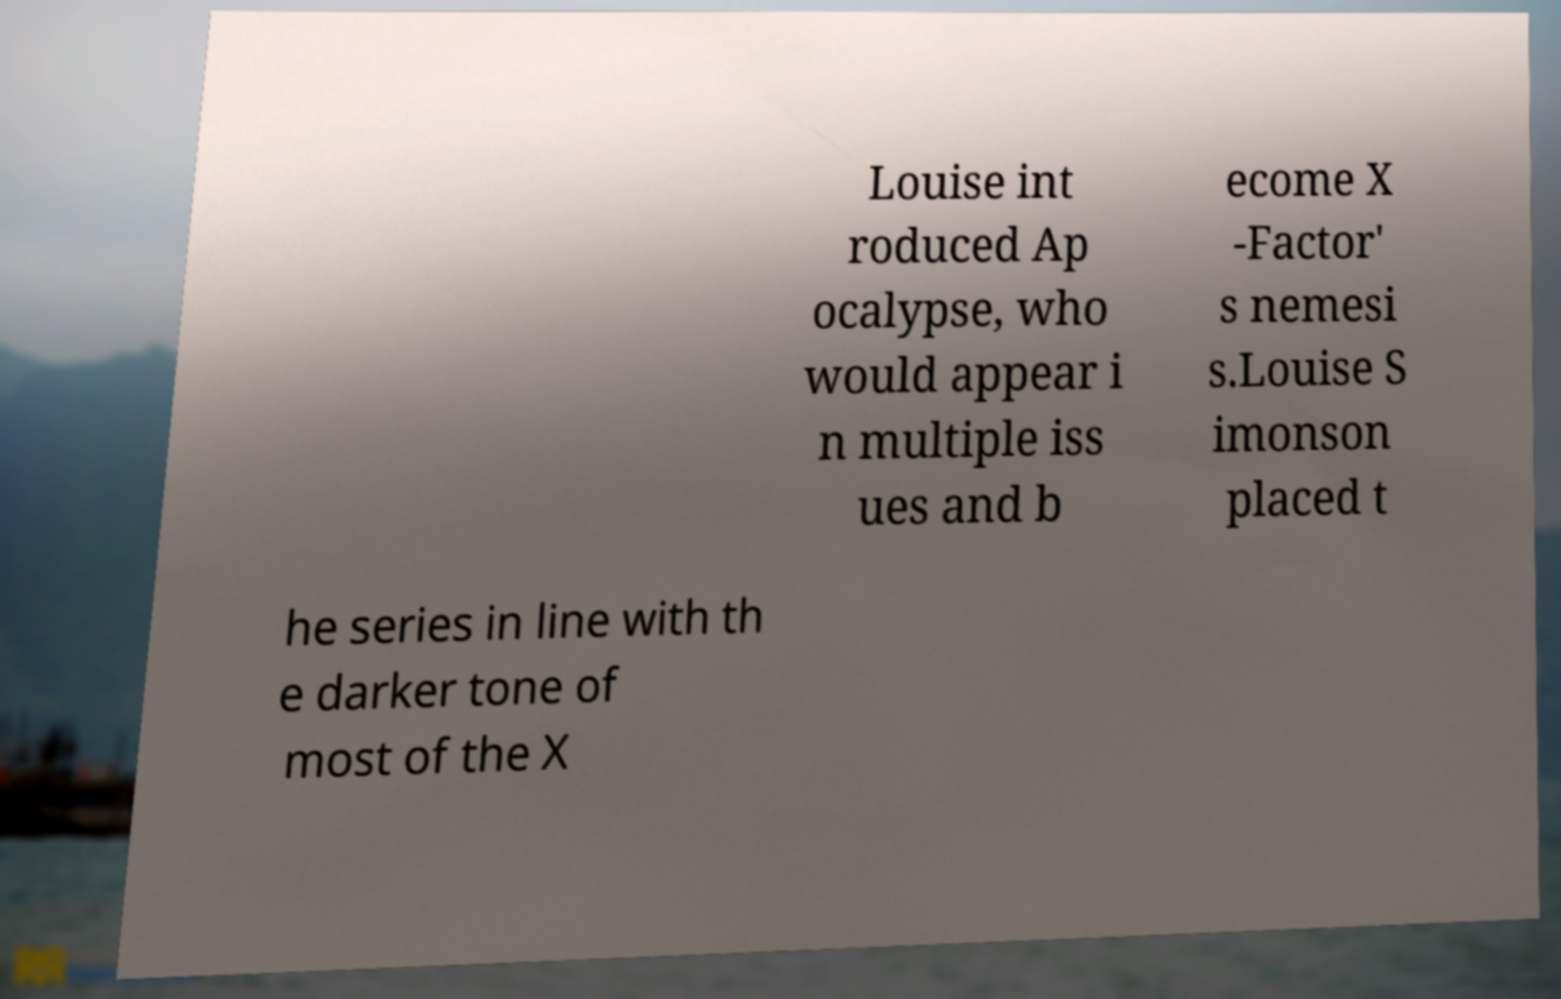Please read and relay the text visible in this image. What does it say? Louise int roduced Ap ocalypse, who would appear i n multiple iss ues and b ecome X -Factor' s nemesi s.Louise S imonson placed t he series in line with th e darker tone of most of the X 